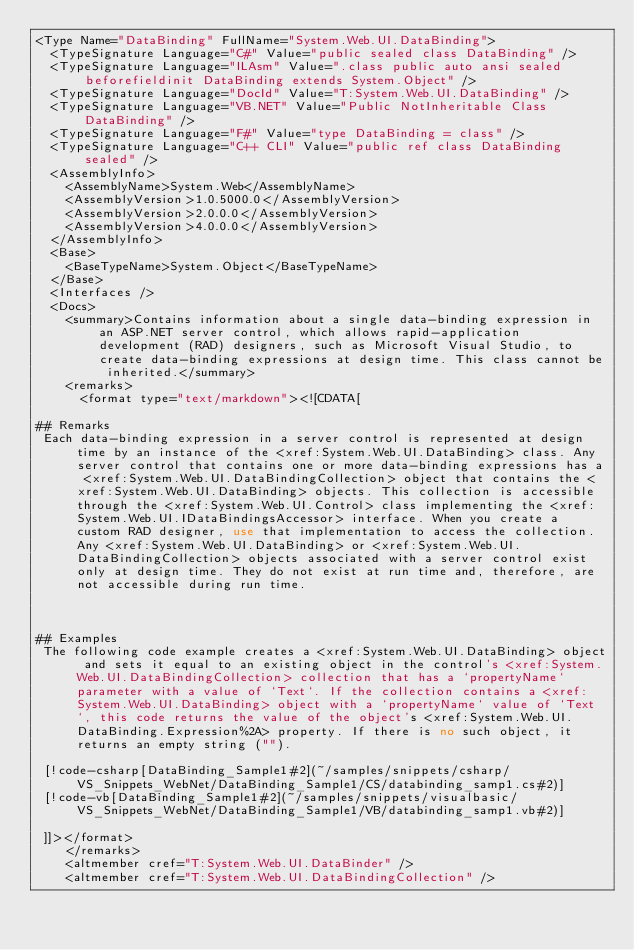<code> <loc_0><loc_0><loc_500><loc_500><_XML_><Type Name="DataBinding" FullName="System.Web.UI.DataBinding">
  <TypeSignature Language="C#" Value="public sealed class DataBinding" />
  <TypeSignature Language="ILAsm" Value=".class public auto ansi sealed beforefieldinit DataBinding extends System.Object" />
  <TypeSignature Language="DocId" Value="T:System.Web.UI.DataBinding" />
  <TypeSignature Language="VB.NET" Value="Public NotInheritable Class DataBinding" />
  <TypeSignature Language="F#" Value="type DataBinding = class" />
  <TypeSignature Language="C++ CLI" Value="public ref class DataBinding sealed" />
  <AssemblyInfo>
    <AssemblyName>System.Web</AssemblyName>
    <AssemblyVersion>1.0.5000.0</AssemblyVersion>
    <AssemblyVersion>2.0.0.0</AssemblyVersion>
    <AssemblyVersion>4.0.0.0</AssemblyVersion>
  </AssemblyInfo>
  <Base>
    <BaseTypeName>System.Object</BaseTypeName>
  </Base>
  <Interfaces />
  <Docs>
    <summary>Contains information about a single data-binding expression in an ASP.NET server control, which allows rapid-application development (RAD) designers, such as Microsoft Visual Studio, to create data-binding expressions at design time. This class cannot be inherited.</summary>
    <remarks>
      <format type="text/markdown"><![CDATA[  
  
## Remarks  
 Each data-binding expression in a server control is represented at design time by an instance of the <xref:System.Web.UI.DataBinding> class. Any server control that contains one or more data-binding expressions has a <xref:System.Web.UI.DataBindingCollection> object that contains the <xref:System.Web.UI.DataBinding> objects. This collection is accessible through the <xref:System.Web.UI.Control> class implementing the <xref:System.Web.UI.IDataBindingsAccessor> interface. When you create a custom RAD designer, use that implementation to access the collection. Any <xref:System.Web.UI.DataBinding> or <xref:System.Web.UI.DataBindingCollection> objects associated with a server control exist only at design time. They do not exist at run time and, therefore, are not accessible during run time.  
  
   
  
## Examples  
 The following code example creates a <xref:System.Web.UI.DataBinding> object and sets it equal to an existing object in the control's <xref:System.Web.UI.DataBindingCollection> collection that has a `propertyName` parameter with a value of `Text`. If the collection contains a <xref:System.Web.UI.DataBinding> object with a `propertyName` value of `Text`, this code returns the value of the object's <xref:System.Web.UI.DataBinding.Expression%2A> property. If there is no such object, it returns an empty string ("").  
  
 [!code-csharp[DataBinding_Sample1#2](~/samples/snippets/csharp/VS_Snippets_WebNet/DataBinding_Sample1/CS/databinding_samp1.cs#2)]
 [!code-vb[DataBinding_Sample1#2](~/samples/snippets/visualbasic/VS_Snippets_WebNet/DataBinding_Sample1/VB/databinding_samp1.vb#2)]  
  
 ]]></format>
    </remarks>
    <altmember cref="T:System.Web.UI.DataBinder" />
    <altmember cref="T:System.Web.UI.DataBindingCollection" /></code> 